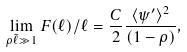<formula> <loc_0><loc_0><loc_500><loc_500>\lim _ { \rho \bar { \ell } \gg 1 } F ( \ell ) / \ell = \frac { C } { 2 } \frac { \langle \psi ^ { \prime } \rangle ^ { 2 } } { ( 1 - \rho ) } ,</formula> 